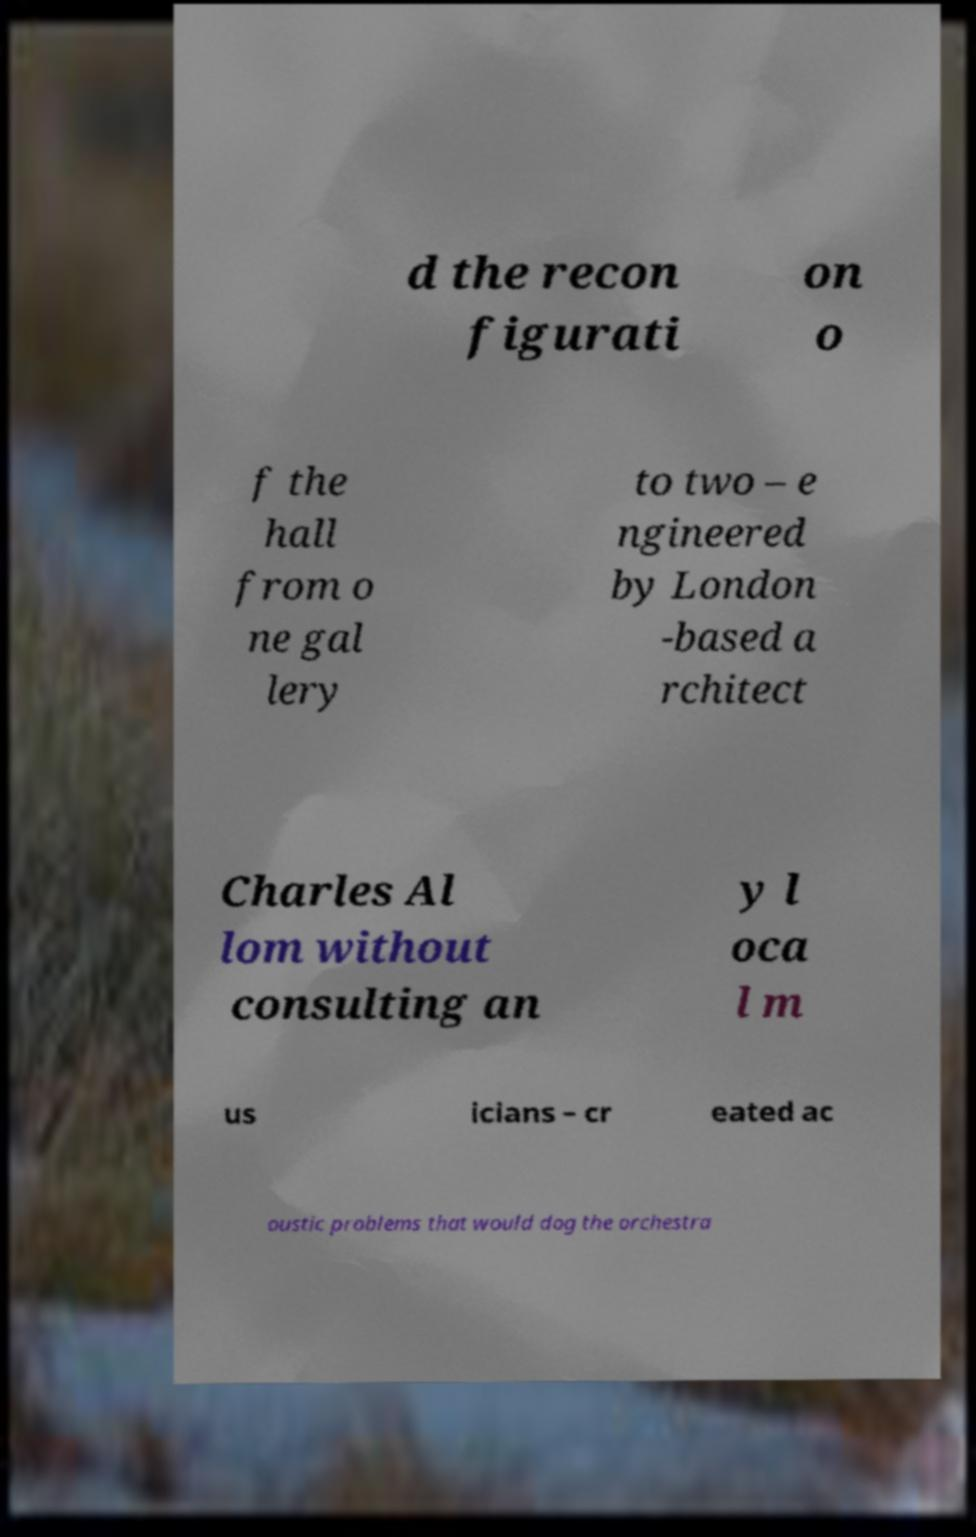Please read and relay the text visible in this image. What does it say? d the recon figurati on o f the hall from o ne gal lery to two – e ngineered by London -based a rchitect Charles Al lom without consulting an y l oca l m us icians – cr eated ac oustic problems that would dog the orchestra 